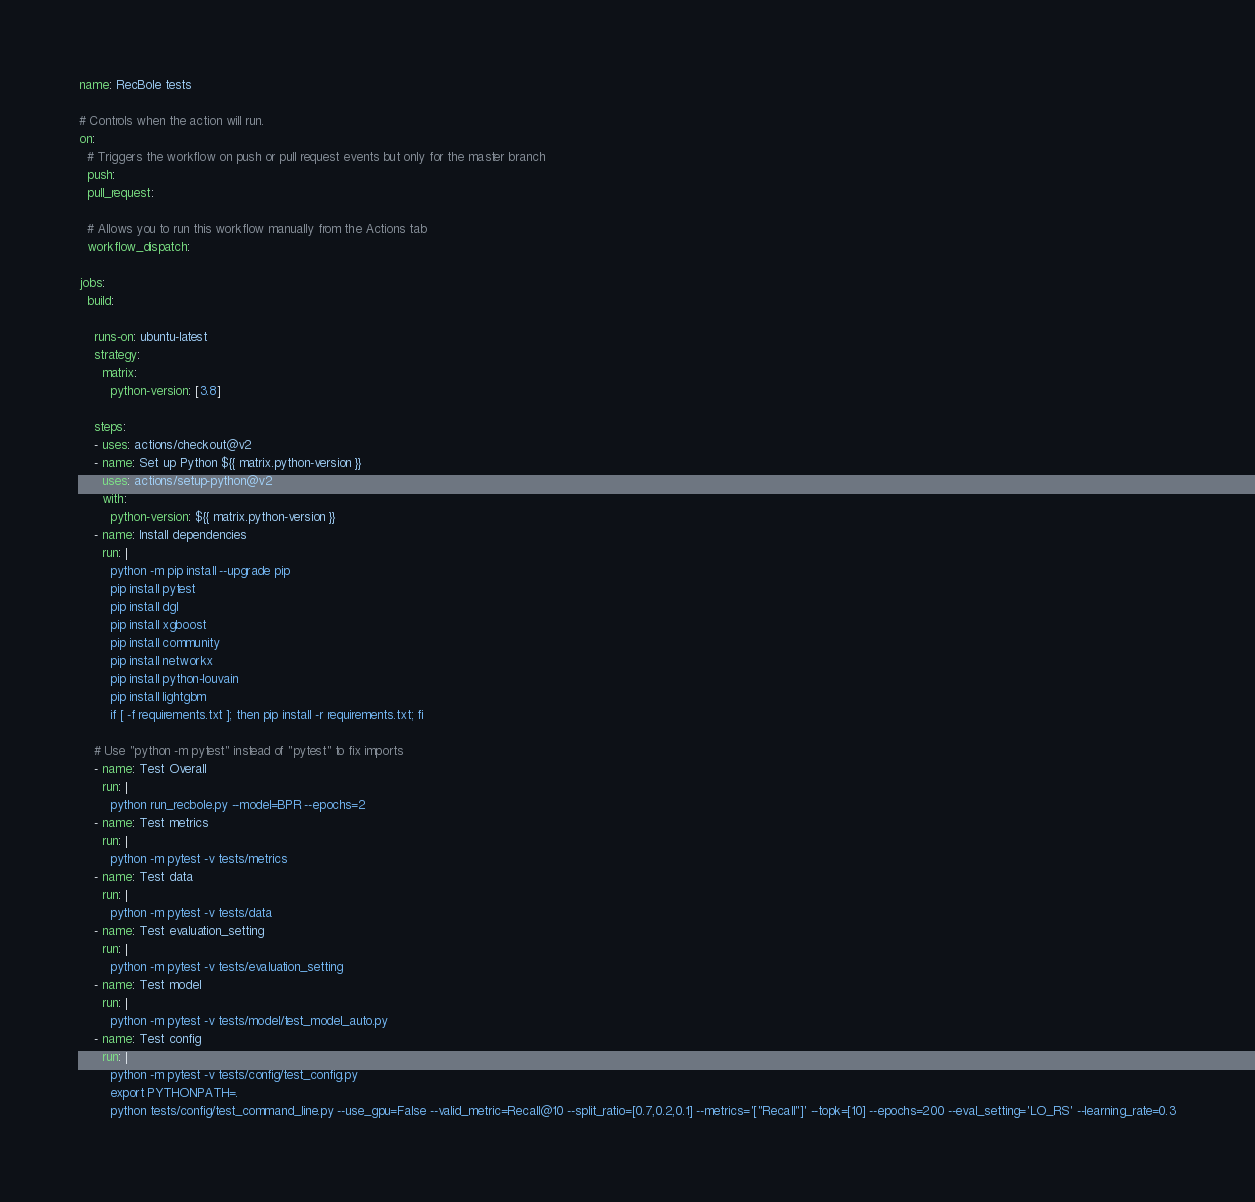Convert code to text. <code><loc_0><loc_0><loc_500><loc_500><_YAML_>name: RecBole tests

# Controls when the action will run. 
on:
  # Triggers the workflow on push or pull request events but only for the master branch
  push:
  pull_request:

  # Allows you to run this workflow manually from the Actions tab
  workflow_dispatch:

jobs:
  build:

    runs-on: ubuntu-latest
    strategy:
      matrix:
        python-version: [3.8]

    steps:
    - uses: actions/checkout@v2
    - name: Set up Python ${{ matrix.python-version }}
      uses: actions/setup-python@v2
      with:
        python-version: ${{ matrix.python-version }}
    - name: Install dependencies
      run: |
        python -m pip install --upgrade pip
        pip install pytest
        pip install dgl
        pip install xgboost
        pip install community
        pip install networkx
        pip install python-louvain
        pip install lightgbm
        if [ -f requirements.txt ]; then pip install -r requirements.txt; fi
        
    # Use "python -m pytest" instead of "pytest" to fix imports
    - name: Test Overall
      run: |
        python run_recbole.py --model=BPR --epochs=2
    - name: Test metrics
      run: |
        python -m pytest -v tests/metrics
    - name: Test data
      run: |
        python -m pytest -v tests/data
    - name: Test evaluation_setting
      run: |
        python -m pytest -v tests/evaluation_setting
    - name: Test model
      run: |
        python -m pytest -v tests/model/test_model_auto.py
    - name: Test config
      run: |
        python -m pytest -v tests/config/test_config.py
        export PYTHONPATH=.
        python tests/config/test_command_line.py --use_gpu=False --valid_metric=Recall@10 --split_ratio=[0.7,0.2,0.1] --metrics='["Recall"]' --topk=[10] --epochs=200 --eval_setting='LO_RS' --learning_rate=0.3

</code> 